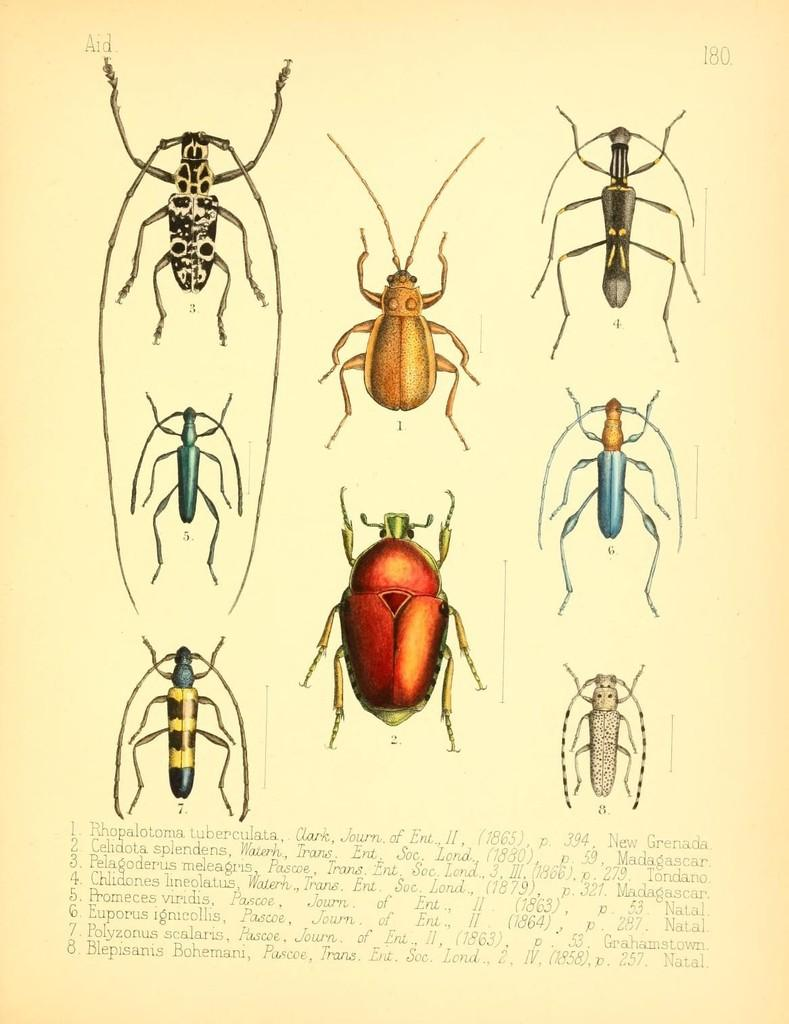What is the main subject of the paper in the image? The paper contains images of insects. Can you describe the insects on the paper? The insects are in different colors. What else can be found on the paper besides the insect images? There is text with numbers on the paper. How many goats can be seen in the image? There are no goats present in the image; it features a paper with images of insects. Can you tell me how many times the insects sneeze in the image? Insects do not sneeze, so this action cannot be observed in the image. 